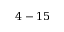<formula> <loc_0><loc_0><loc_500><loc_500>4 - 1 5</formula> 